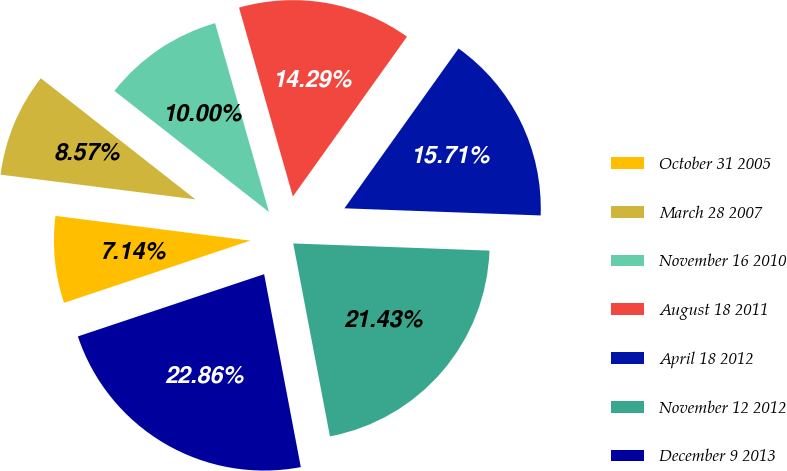Convert chart to OTSL. <chart><loc_0><loc_0><loc_500><loc_500><pie_chart><fcel>October 31 2005<fcel>March 28 2007<fcel>November 16 2010<fcel>August 18 2011<fcel>April 18 2012<fcel>November 12 2012<fcel>December 9 2013<nl><fcel>7.14%<fcel>8.57%<fcel>10.0%<fcel>14.29%<fcel>15.71%<fcel>21.43%<fcel>22.86%<nl></chart> 